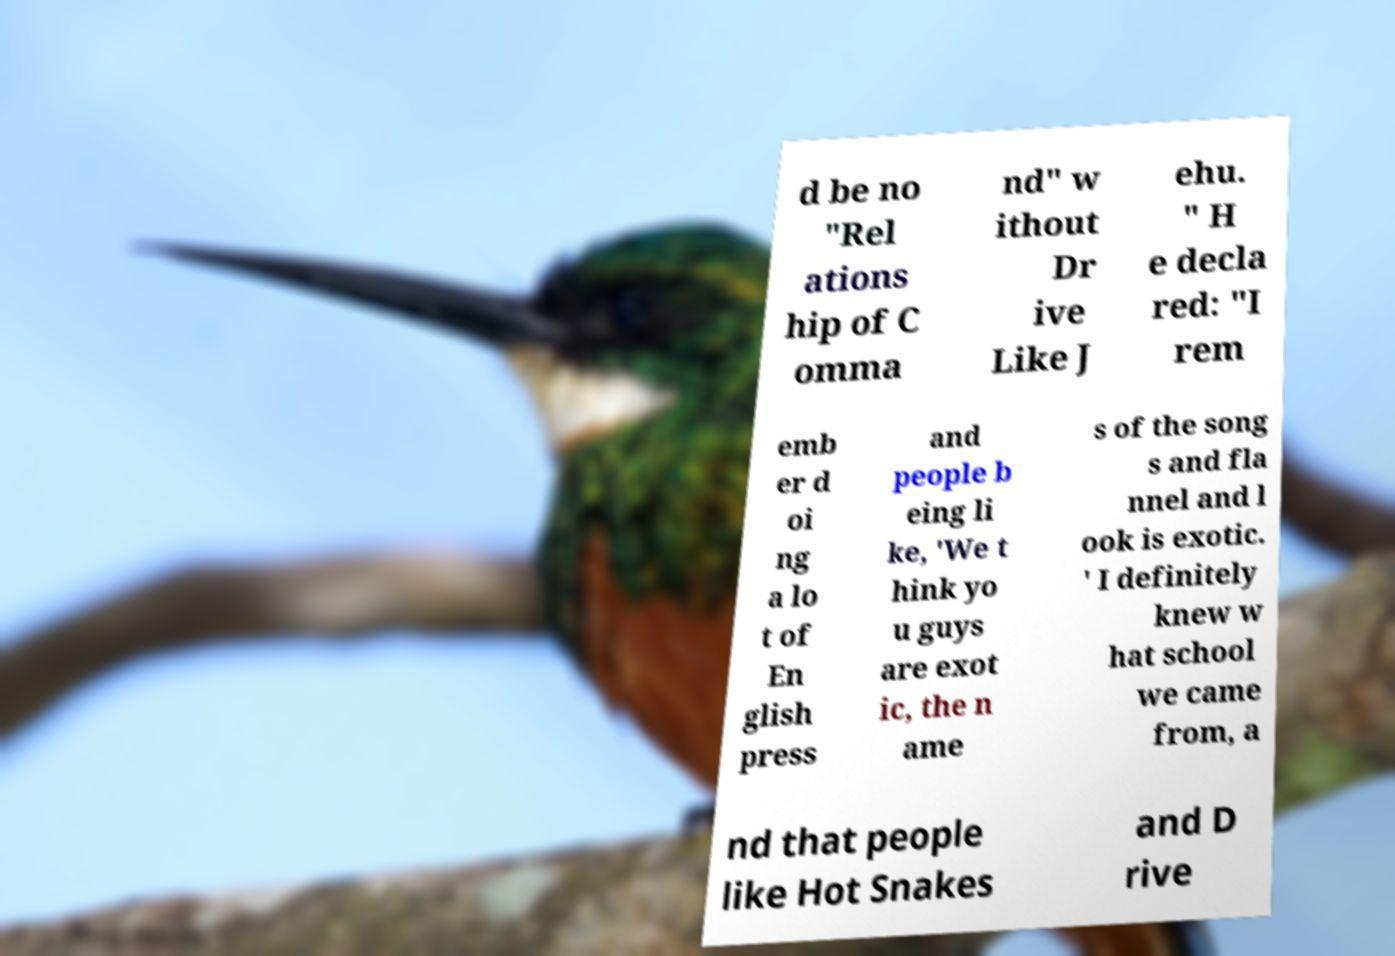Could you extract and type out the text from this image? d be no "Rel ations hip of C omma nd" w ithout Dr ive Like J ehu. " H e decla red: "I rem emb er d oi ng a lo t of En glish press and people b eing li ke, 'We t hink yo u guys are exot ic, the n ame s of the song s and fla nnel and l ook is exotic. ' I definitely knew w hat school we came from, a nd that people like Hot Snakes and D rive 